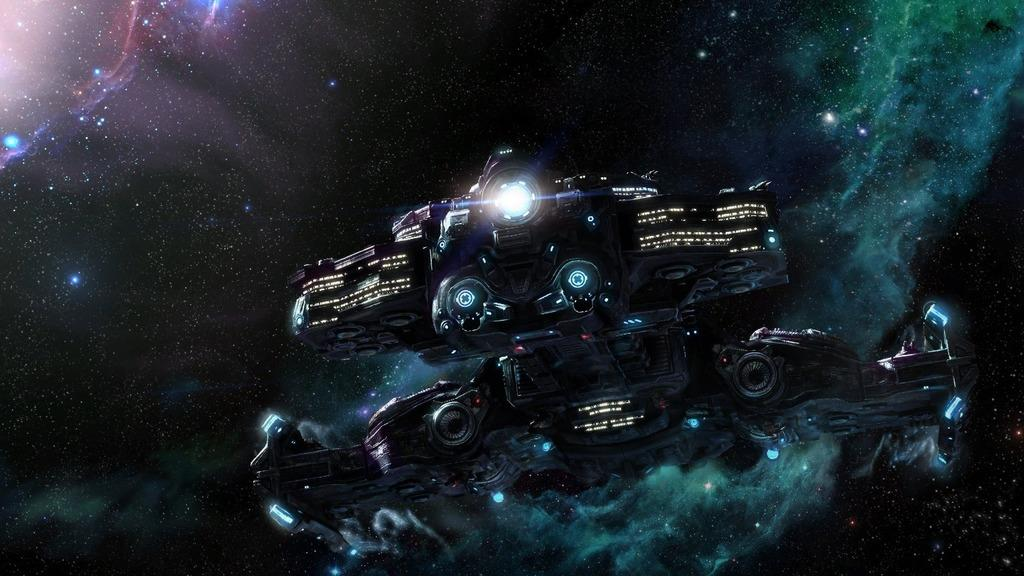What is the main subject of the image? There is a spaceship in the image. What can be seen in the background of the image? The sky is visible in the background of the image. What celestial objects are present in the sky? Stars are present in the sky. What type of circle is being played on the guitar in the image? There is no guitar or circle present in the image; it features a spaceship and stars in the sky. 